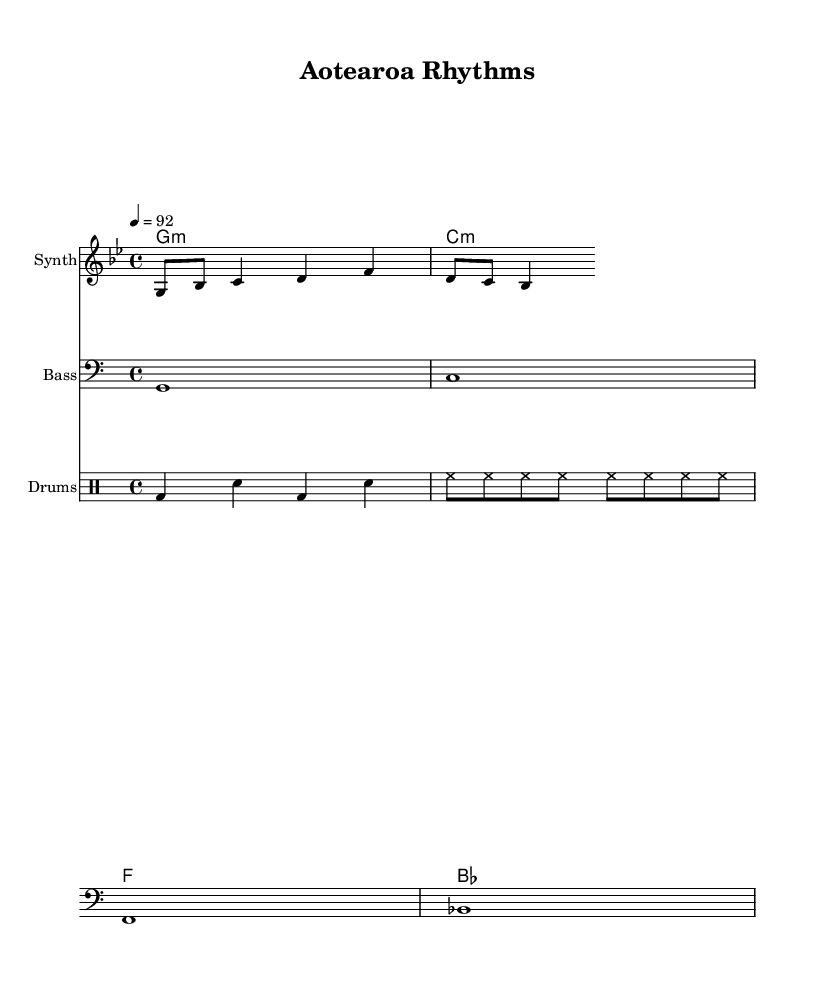What is the key signature of this music? The key signature indicated is G minor, which has two flats. This can be determined by looking at the key signature at the beginning of the score.
Answer: G minor What is the time signature used in this piece? The time signature at the beginning of the score is 4/4, meaning there are four beats per measure and a quarter note gets one beat. This is clearly noted on the staff.
Answer: 4/4 What is the tempo marking for this piece? The tempo marking indicates 92 beats per minute, which suggests a moderate pace. This is specified in the tempo instruction at the beginning of the score.
Answer: 92 How many measures are present in the melody? The melody presented contains one complete measure as indicated by the bar lines, which separate musical phrases.
Answer: 1 What type of instrument is playing the melody? The instrument designated for the melody is a "Synth," which is noted on the staff label. This indicates a synthesized sound typical in hip hop music.
Answer: Synth What kind of drum patterns are used here? The drum patterns include a bass drum and snare alternation, which is characteristic of hip hop tracks for their rhythmic drive. This can be deduced by observing the notation in the drum staff.
Answer: Bass and snare What is the first chord played in the harmony part? The first chord indicated is G minor, which is seen as the first element in the chord names section. This chord sets the tonal foundation for the rest of the piece.
Answer: G minor 